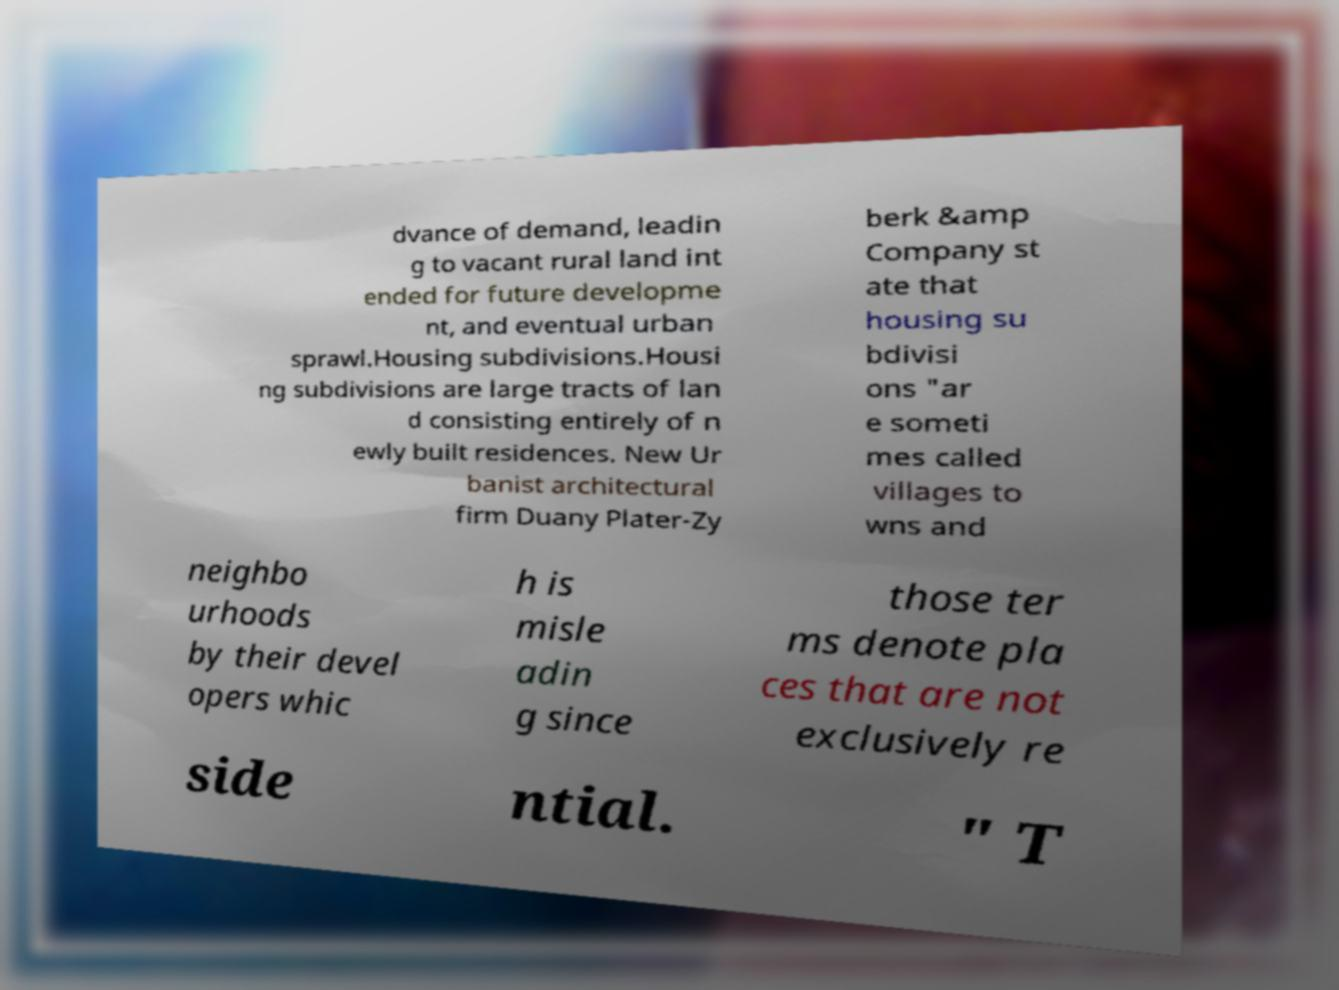Can you read and provide the text displayed in the image?This photo seems to have some interesting text. Can you extract and type it out for me? dvance of demand, leadin g to vacant rural land int ended for future developme nt, and eventual urban sprawl.Housing subdivisions.Housi ng subdivisions are large tracts of lan d consisting entirely of n ewly built residences. New Ur banist architectural firm Duany Plater-Zy berk &amp Company st ate that housing su bdivisi ons "ar e someti mes called villages to wns and neighbo urhoods by their devel opers whic h is misle adin g since those ter ms denote pla ces that are not exclusively re side ntial. " T 